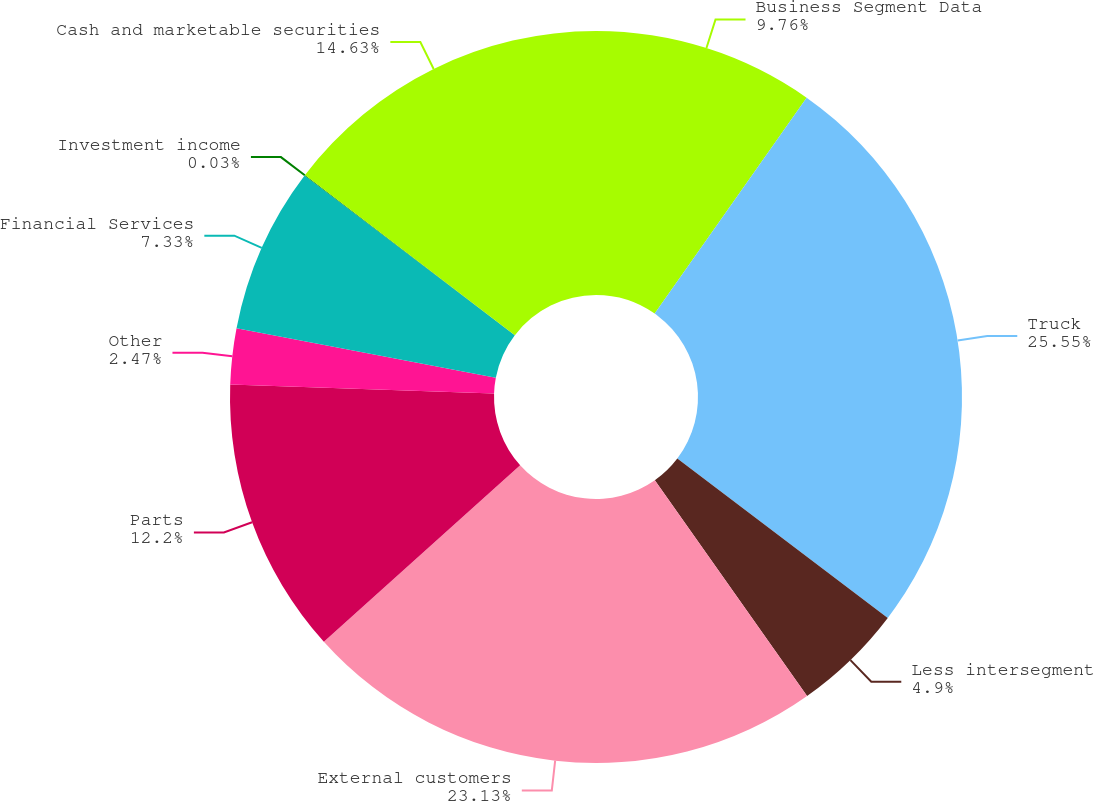Convert chart to OTSL. <chart><loc_0><loc_0><loc_500><loc_500><pie_chart><fcel>Business Segment Data<fcel>Truck<fcel>Less intersegment<fcel>External customers<fcel>Parts<fcel>Other<fcel>Financial Services<fcel>Investment income<fcel>Cash and marketable securities<nl><fcel>9.76%<fcel>25.56%<fcel>4.9%<fcel>23.13%<fcel>12.2%<fcel>2.47%<fcel>7.33%<fcel>0.03%<fcel>14.63%<nl></chart> 